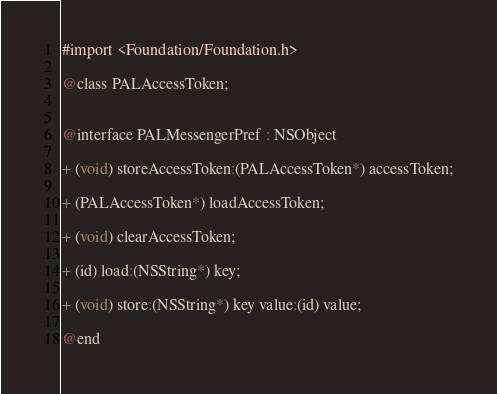<code> <loc_0><loc_0><loc_500><loc_500><_C_>#import <Foundation/Foundation.h>

@class PALAccessToken;


@interface PALMessengerPref : NSObject

+ (void) storeAccessToken:(PALAccessToken*) accessToken;

+ (PALAccessToken*) loadAccessToken;

+ (void) clearAccessToken;

+ (id) load:(NSString*) key;

+ (void) store:(NSString*) key value:(id) value;

@end
</code> 